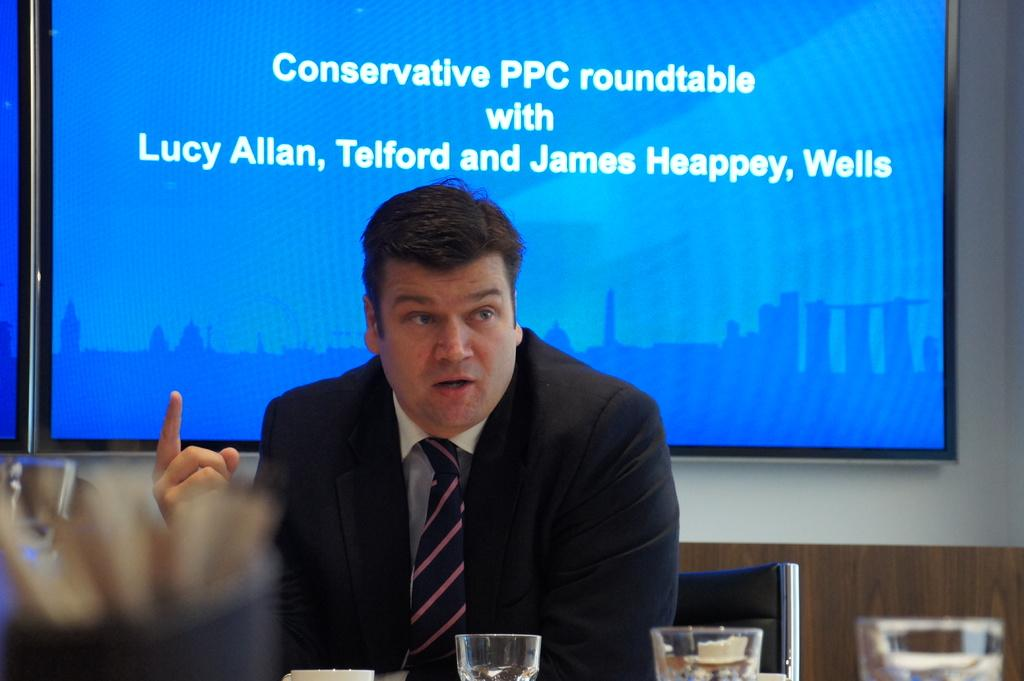What is the main subject of the image? There is a person in the image. What is the person doing in the image? The person is sitting on a chair. What can be seen in the background of the image? There is a projector screen in the background of the image. What type of leather is the person wearing in the image? There is no mention of leather or any clothing in the image, so it cannot be determined what type of leather the person might be wearing. 